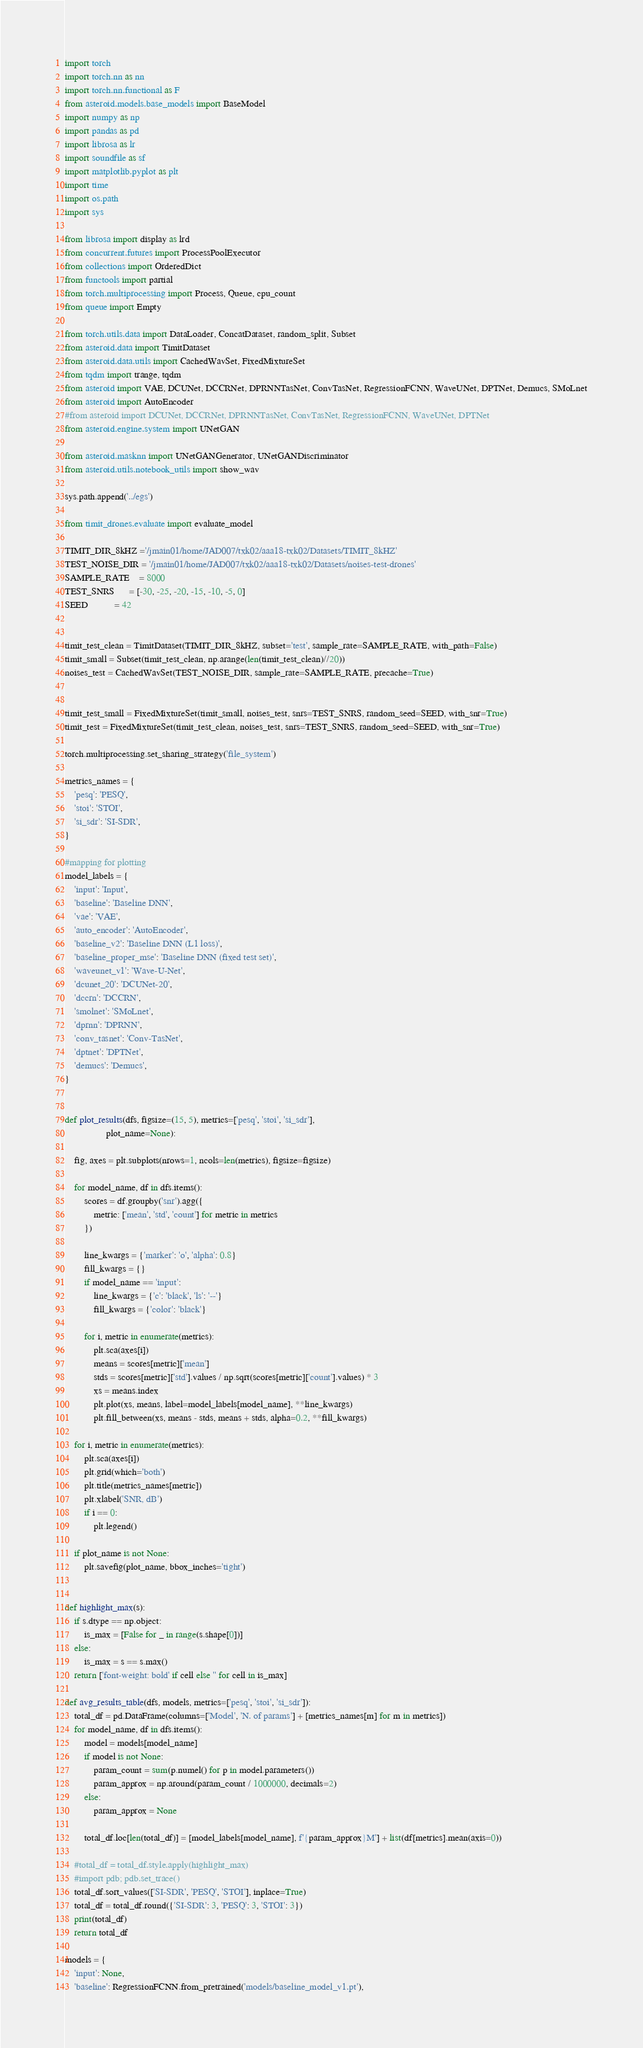Convert code to text. <code><loc_0><loc_0><loc_500><loc_500><_Python_>import torch
import torch.nn as nn
import torch.nn.functional as F
from asteroid.models.base_models import BaseModel
import numpy as np
import pandas as pd
import librosa as lr
import soundfile as sf
import matplotlib.pyplot as plt
import time
import os.path
import sys

from librosa import display as lrd
from concurrent.futures import ProcessPoolExecutor
from collections import OrderedDict
from functools import partial
from torch.multiprocessing import Process, Queue, cpu_count
from queue import Empty

from torch.utils.data import DataLoader, ConcatDataset, random_split, Subset
from asteroid.data import TimitDataset
from asteroid.data.utils import CachedWavSet, FixedMixtureSet
from tqdm import trange, tqdm
from asteroid import VAE, DCUNet, DCCRNet, DPRNNTasNet, ConvTasNet, RegressionFCNN, WaveUNet, DPTNet, Demucs, SMoLnet
from asteroid import AutoEncoder 
#from asteroid import DCUNet, DCCRNet, DPRNNTasNet, ConvTasNet, RegressionFCNN, WaveUNet, DPTNet
from asteroid.engine.system import UNetGAN

from asteroid.masknn import UNetGANGenerator, UNetGANDiscriminator
from asteroid.utils.notebook_utils import show_wav

sys.path.append('../egs')

from timit_drones.evaluate import evaluate_model

TIMIT_DIR_8kHZ ='/jmain01/home/JAD007/txk02/aaa18-txk02/Datasets/TIMIT_8kHZ' 
TEST_NOISE_DIR = '/jmain01/home/JAD007/txk02/aaa18-txk02/Datasets/noises-test-drones'
SAMPLE_RATE    = 8000
TEST_SNRS      = [-30, -25, -20, -15, -10, -5, 0]
SEED           = 42


timit_test_clean = TimitDataset(TIMIT_DIR_8kHZ, subset='test', sample_rate=SAMPLE_RATE, with_path=False)
timit_small = Subset(timit_test_clean, np.arange(len(timit_test_clean)//20))
noises_test = CachedWavSet(TEST_NOISE_DIR, sample_rate=SAMPLE_RATE, precache=True)


timit_test_small = FixedMixtureSet(timit_small, noises_test, snrs=TEST_SNRS, random_seed=SEED, with_snr=True)
timit_test = FixedMixtureSet(timit_test_clean, noises_test, snrs=TEST_SNRS, random_seed=SEED, with_snr=True)

torch.multiprocessing.set_sharing_strategy('file_system')

metrics_names = {
    'pesq': 'PESQ',
    'stoi': 'STOI',
    'si_sdr': 'SI-SDR',
}

#mapping for plotting
model_labels = {
    'input': 'Input',
    'baseline': 'Baseline DNN',
    'vae': 'VAE',
    'auto_encoder': 'AutoEncoder',
    'baseline_v2': 'Baseline DNN (L1 loss)',
    'baseline_proper_mse': 'Baseline DNN (fixed test set)',
    'waveunet_v1': 'Wave-U-Net',
    'dcunet_20': 'DCUNet-20',
    'dccrn': 'DCCRN',
    'smolnet': 'SMoLnet',
    'dprnn': 'DPRNN',
    'conv_tasnet': 'Conv-TasNet',
    'dptnet': 'DPTNet',
    'demucs': 'Demucs',
}


def plot_results(dfs, figsize=(15, 5), metrics=['pesq', 'stoi', 'si_sdr'],
                 plot_name=None):

    fig, axes = plt.subplots(nrows=1, ncols=len(metrics), figsize=figsize)

    for model_name, df in dfs.items():
        scores = df.groupby('snr').agg({
            metric: ['mean', 'std', 'count'] for metric in metrics
        })

        line_kwargs = {'marker': 'o', 'alpha': 0.8}
        fill_kwargs = {}
        if model_name == 'input':
            line_kwargs = {'c': 'black', 'ls': '--'}
            fill_kwargs = {'color': 'black'}

        for i, metric in enumerate(metrics):
            plt.sca(axes[i])
            means = scores[metric]['mean']
            stds = scores[metric]['std'].values / np.sqrt(scores[metric]['count'].values) * 3
            xs = means.index
            plt.plot(xs, means, label=model_labels[model_name], **line_kwargs)
            plt.fill_between(xs, means - stds, means + stds, alpha=0.2, **fill_kwargs)

    for i, metric in enumerate(metrics):
        plt.sca(axes[i])
        plt.grid(which='both')
        plt.title(metrics_names[metric])
        plt.xlabel('SNR, dB')
        if i == 0:
            plt.legend()

    if plot_name is not None:
        plt.savefig(plot_name, bbox_inches='tight')


def highlight_max(s): 
    if s.dtype == np.object: 
        is_max = [False for _ in range(s.shape[0])] 
    else: 
        is_max = s == s.max() 
    return ['font-weight: bold' if cell else '' for cell in is_max] 

def avg_results_table(dfs, models, metrics=['pesq', 'stoi', 'si_sdr']):
    total_df = pd.DataFrame(columns=['Model', 'N. of params'] + [metrics_names[m] for m in metrics])
    for model_name, df in dfs.items():
        model = models[model_name]
        if model is not None:
            param_count = sum(p.numel() for p in model.parameters())
            param_approx = np.around(param_count / 1000000, decimals=2)
        else:
            param_approx = None

        total_df.loc[len(total_df)] = [model_labels[model_name], f'{param_approx}M'] + list(df[metrics].mean(axis=0))

    #total_df = total_df.style.apply(highlight_max)
    #import pdb; pdb.set_trace()
    total_df.sort_values(['SI-SDR', 'PESQ', 'STOI'], inplace=True)
    total_df = total_df.round({'SI-SDR': 3, 'PESQ': 3, 'STOI': 3})
    print(total_df)
    return total_df

models = {
    'input': None,
    'baseline': RegressionFCNN.from_pretrained('models/baseline_model_v1.pt'),</code> 